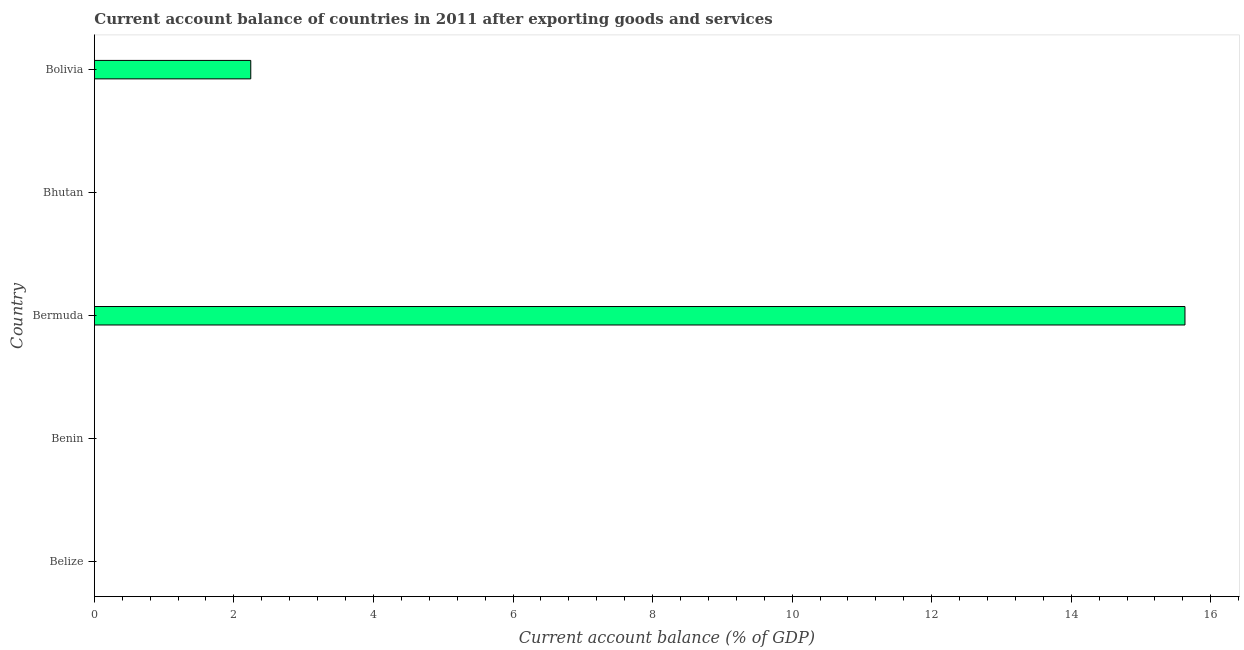What is the title of the graph?
Offer a very short reply. Current account balance of countries in 2011 after exporting goods and services. What is the label or title of the X-axis?
Give a very brief answer. Current account balance (% of GDP). What is the label or title of the Y-axis?
Provide a succinct answer. Country. What is the current account balance in Bermuda?
Keep it short and to the point. 15.63. Across all countries, what is the maximum current account balance?
Provide a short and direct response. 15.63. In which country was the current account balance maximum?
Your answer should be very brief. Bermuda. What is the sum of the current account balance?
Offer a terse response. 17.87. What is the difference between the current account balance in Bermuda and Bolivia?
Offer a terse response. 13.39. What is the average current account balance per country?
Ensure brevity in your answer.  3.57. What is the median current account balance?
Provide a short and direct response. 0. In how many countries, is the current account balance greater than 11.6 %?
Keep it short and to the point. 1. What is the difference between the highest and the lowest current account balance?
Your answer should be very brief. 15.63. In how many countries, is the current account balance greater than the average current account balance taken over all countries?
Make the answer very short. 1. How many bars are there?
Your answer should be compact. 2. How many countries are there in the graph?
Your answer should be very brief. 5. What is the difference between two consecutive major ticks on the X-axis?
Give a very brief answer. 2. Are the values on the major ticks of X-axis written in scientific E-notation?
Your answer should be very brief. No. What is the Current account balance (% of GDP) in Belize?
Your answer should be very brief. 0. What is the Current account balance (% of GDP) in Benin?
Offer a terse response. 0. What is the Current account balance (% of GDP) of Bermuda?
Make the answer very short. 15.63. What is the Current account balance (% of GDP) of Bolivia?
Provide a short and direct response. 2.24. What is the difference between the Current account balance (% of GDP) in Bermuda and Bolivia?
Give a very brief answer. 13.39. What is the ratio of the Current account balance (% of GDP) in Bermuda to that in Bolivia?
Offer a very short reply. 6.97. 